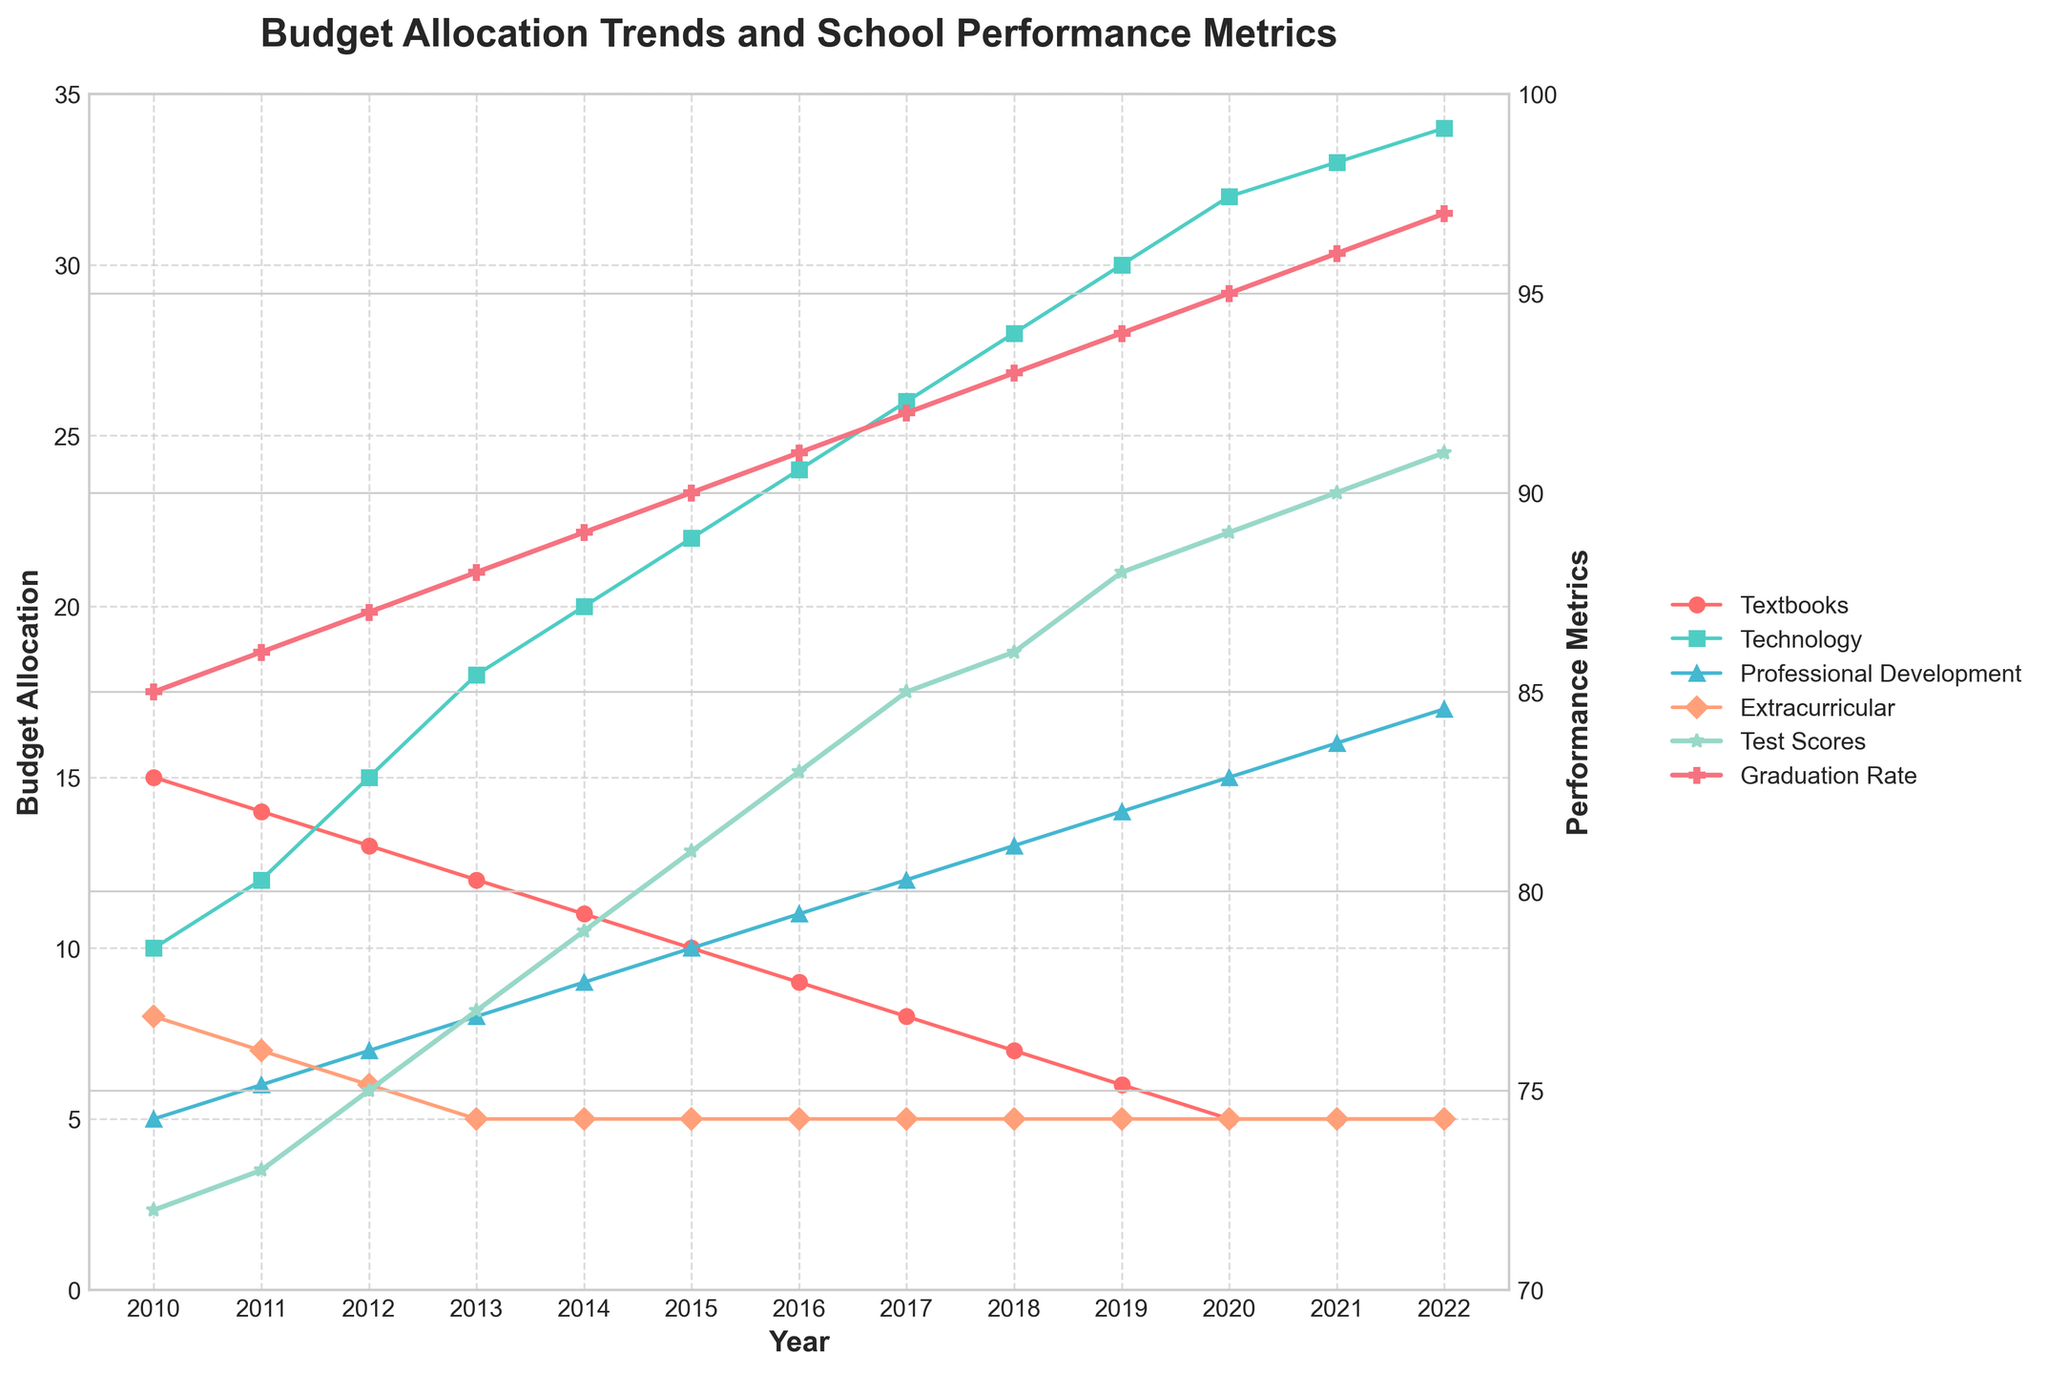What is the trend of the budget allocation for textbooks from 2010 to 2022? The budget allocation for textbooks has steadily decreased from 15 units in 2010 to 5 units in 2022, showing a consistent downward trend over the years.
Answer: The budget allocation for textbooks has steadily decreased from 15 units in 2010 to 5 units in 2022 Which year had the highest budget allocation for technology, and how much was it? By visually examining the figure, the highest budget allocation for technology occurred in 2022 with 34 units.
Answer: 2022, 34 units In which year did professional development budget allocation first surpass extracurricular activities, and what were the respective values? The professional development budget first surpassed extracurricular activities in 2013, with professional development at 8 units and extracurricular activities at 5 units.
Answer: 2013, 8 units for professional development; 5 units for extracurricular activities Compare the trend of test scores and graduation rates from 2010 to 2022. Which one increased at a faster rate? Both test scores and graduation rates showed an upward trend from 2010 to 2022. Test scores increased from 72 to 91 (a difference of 19 units) while graduation rates increased from 85 to 97 (a difference of 12 units). Test scores increased at a faster rate.
Answer: Test scores increased at a faster rate Does an increase in the technology budget seem to correlate with an increase in test scores? From the visual trend, as the technology budget increased significantly from 10 units in 2010 to 34 units in 2022, the test scores also increased from 72 to 91. This suggests a positive correlation between the increase in technology budget and test scores.
Answer: Yes, there seems to be a positive correlation What was the budget allocation difference between professional development and extracurricular activities in 2018? In 2018, professional development had a budget allocation of 13 units, while extracurricular activities had 5 units. The difference is 13 - 5 = 8 units.
Answer: 8 units What significant trend can you observe for the budget allocation for extracurricular activities over the years? The budget allocation for extracurricular activities remained constant at 5 units from 2013 onwards, despite variations in other budget categories.
Answer: It remained constant at 5 units from 2013 onwards Which years show a plateau in the graduation rate, and what is the plateau value? The graduation rate shows a plateau at 96 units in the years 2021 and 2022.
Answer: 2021 and 2022, value is 96 Is there a year where all budget allocations (Textbooks, Technology, Professional Development, and Extracurricular) either increased, decreased, or remained the same compared to the previous year? In the year 2021, the budget allocations for technology and professional development both increased, while textbooks and extracurricular activities remained the same compared to 2020. None of the categories decreased.
Answer: 2021 What is the combined budget allocation for technology and professional development in 2015, and how does this compare to the total combined budget in 2022? In 2015, the combined budget allocation for technology (22 units) and professional development (10 units) is 22 + 10 = 32 units. In 2022, the combined budget for technology (34 units) and professional development (17 units) is 34 + 17 = 51 units. The 2022 combined budget is 19 units higher than in 2015.
Answer: 32 units in 2015, 51 units in 2022; 19 units higher in 2022 